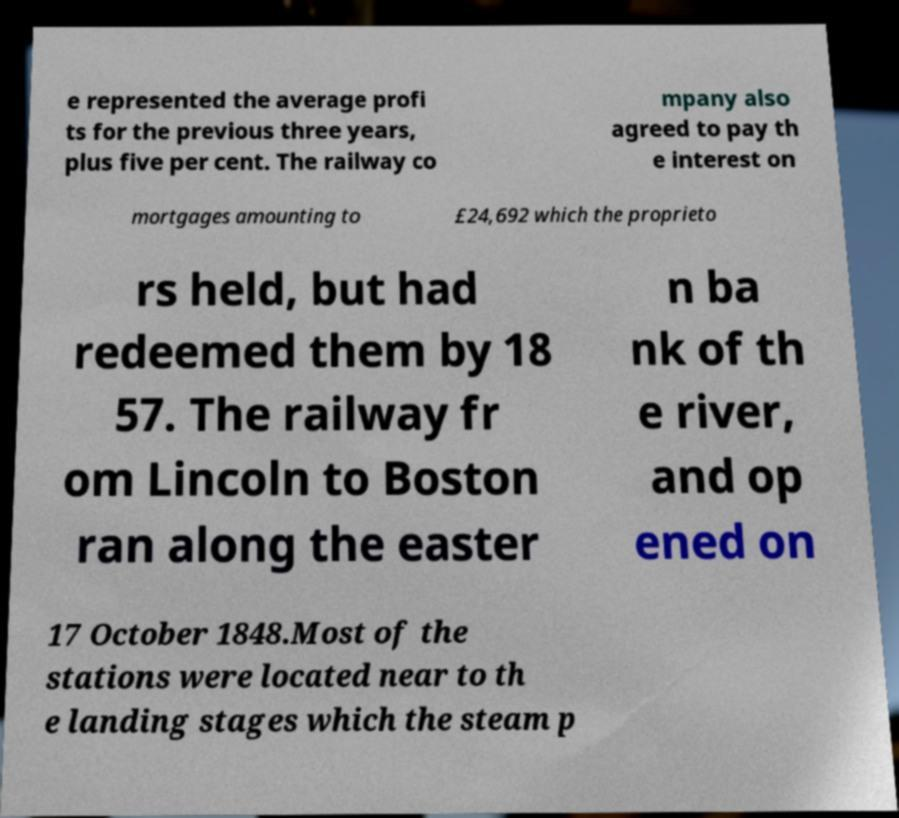Please read and relay the text visible in this image. What does it say? e represented the average profi ts for the previous three years, plus five per cent. The railway co mpany also agreed to pay th e interest on mortgages amounting to £24,692 which the proprieto rs held, but had redeemed them by 18 57. The railway fr om Lincoln to Boston ran along the easter n ba nk of th e river, and op ened on 17 October 1848.Most of the stations were located near to th e landing stages which the steam p 